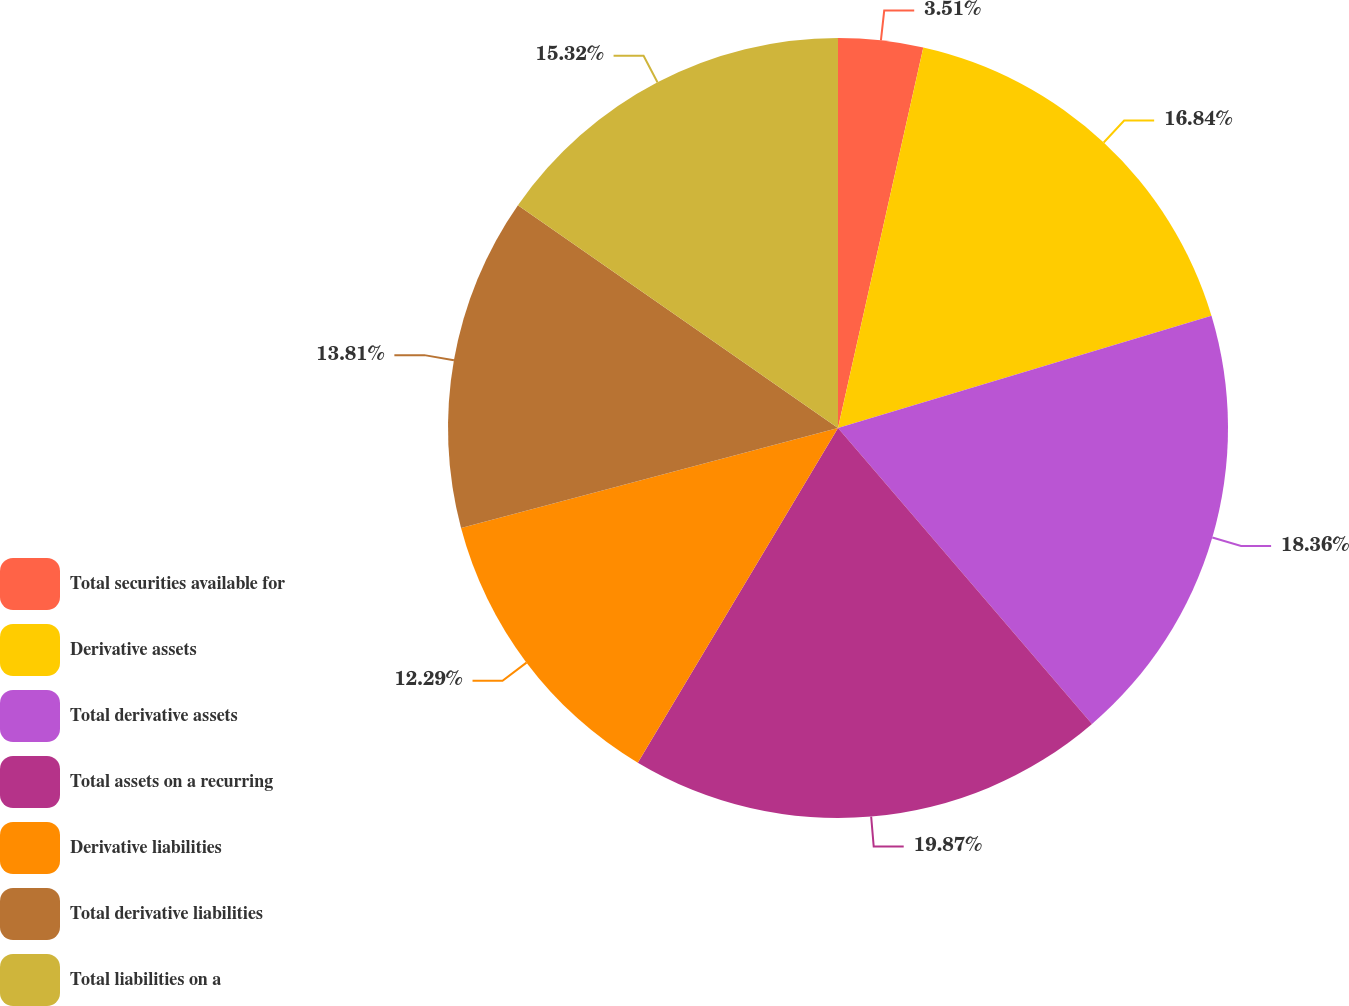Convert chart. <chart><loc_0><loc_0><loc_500><loc_500><pie_chart><fcel>Total securities available for<fcel>Derivative assets<fcel>Total derivative assets<fcel>Total assets on a recurring<fcel>Derivative liabilities<fcel>Total derivative liabilities<fcel>Total liabilities on a<nl><fcel>3.51%<fcel>16.84%<fcel>18.36%<fcel>19.87%<fcel>12.29%<fcel>13.81%<fcel>15.32%<nl></chart> 